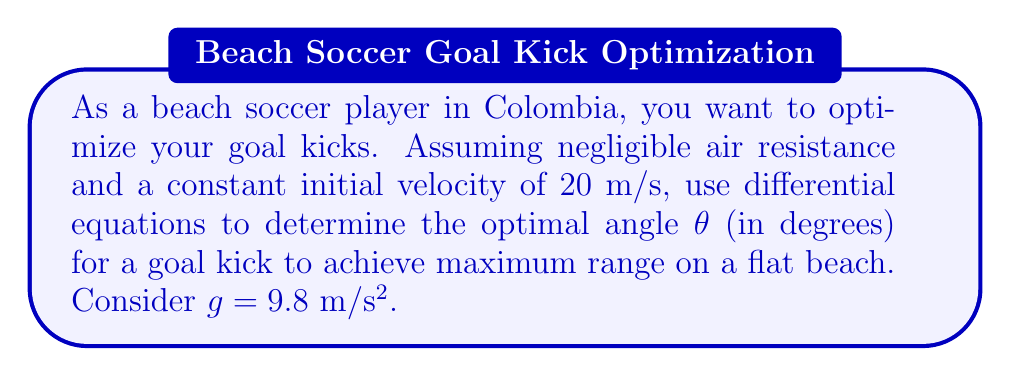Show me your answer to this math problem. Let's approach this step-by-step using differential equations:

1) The motion of the ball can be described by two differential equations:

   $$\frac{d^2x}{dt^2} = 0$$
   $$\frac{d^2y}{dt^2} = -g$$

   Where x is horizontal distance and y is vertical distance.

2) Integrating these equations once:

   $$\frac{dx}{dt} = v_0 \cos(\theta)$$
   $$\frac{dy}{dt} = v_0 \sin(\theta) - gt$$

   Where $v_0$ is the initial velocity and θ is the launch angle.

3) Integrating again:

   $$x = v_0 t \cos(\theta)$$
   $$y = v_0 t \sin(\theta) - \frac{1}{2}gt^2$$

4) The range R is the value of x when y = 0 (when the ball hits the ground). Solving for t when y = 0:

   $$0 = v_0 t \sin(\theta) - \frac{1}{2}gt^2$$
   $$t = \frac{2v_0 \sin(\theta)}{g}$$

5) Substituting this t into the equation for x gives us the range R:

   $$R = v_0 (\frac{2v_0 \sin(\theta)}{g}) \cos(\theta) = \frac{2v_0^2}{g} \sin(\theta)\cos(\theta)$$

6) Using the trigonometric identity $\sin(2\theta) = 2\sin(\theta)\cos(\theta)$, we get:

   $$R = \frac{v_0^2}{g} \sin(2\theta)$$

7) To find the maximum range, we differentiate R with respect to θ and set it to zero:

   $$\frac{dR}{d\theta} = \frac{v_0^2}{g} 2\cos(2\theta) = 0$$

8) This is satisfied when $\cos(2\theta) = 0$, which occurs when $2\theta = 90°$ or $\theta = 45°$.

9) Substituting the given values ($v_0 = 20$ m/s, $g = 9.8$ m/s²) into the range equation confirms that the maximum range occurs at 45°.

Therefore, the optimal angle for maximum range is 45°.
Answer: The optimal angle θ for a beach soccer goal kick to achieve maximum range is 45°. 